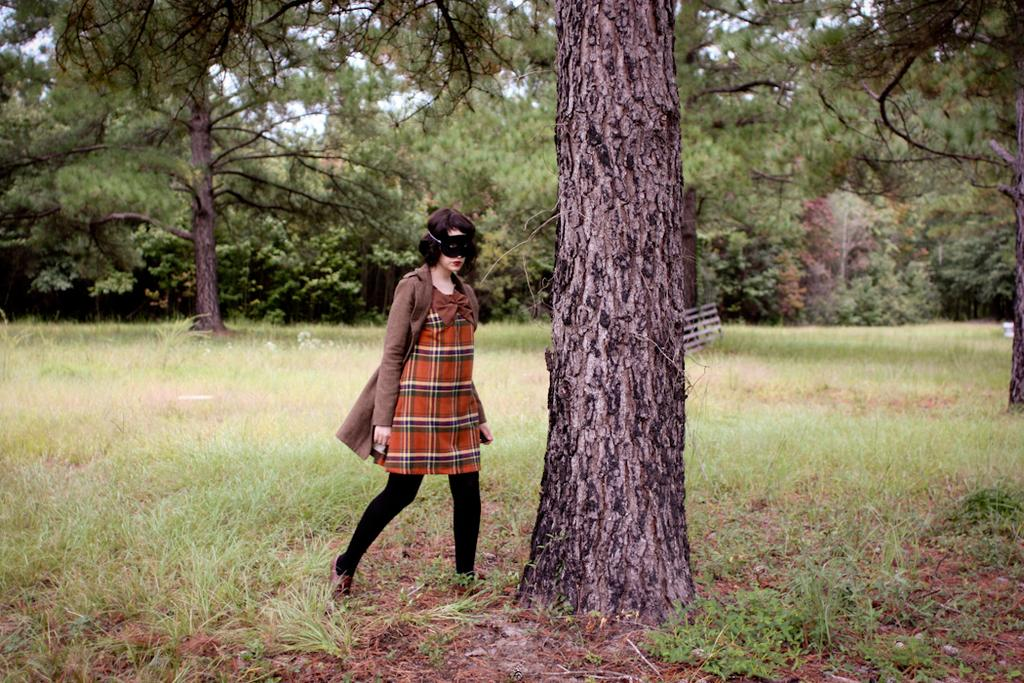Who is present in the image? There is a woman in the image. What is the woman wearing on her face? The woman is wearing a mask. What type of natural environment can be seen in the background of the image? There are trees and grass in the background of the image. What part of the natural environment is visible in the image? The sky is visible in the background of the image. What type of shock can be seen in the image? There is no shock present in the image. What type of light is being used to illuminate the scene in the image? The image does not provide information about the type of light being used. 